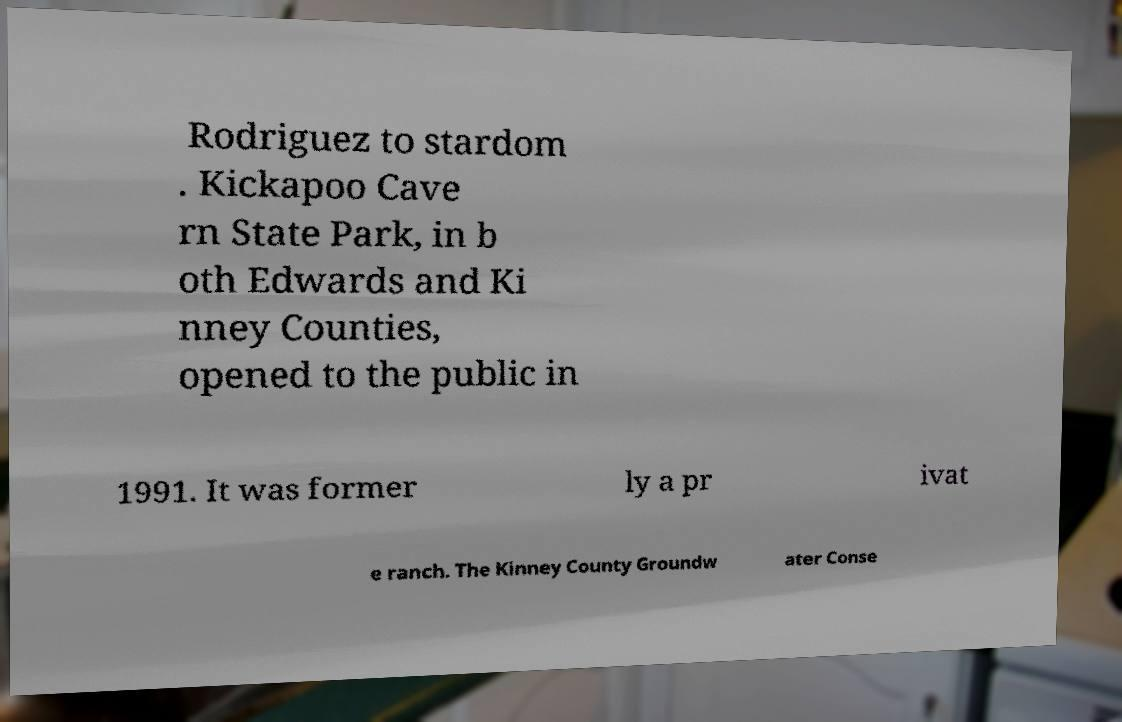Can you accurately transcribe the text from the provided image for me? Rodriguez to stardom . Kickapoo Cave rn State Park, in b oth Edwards and Ki nney Counties, opened to the public in 1991. It was former ly a pr ivat e ranch. The Kinney County Groundw ater Conse 